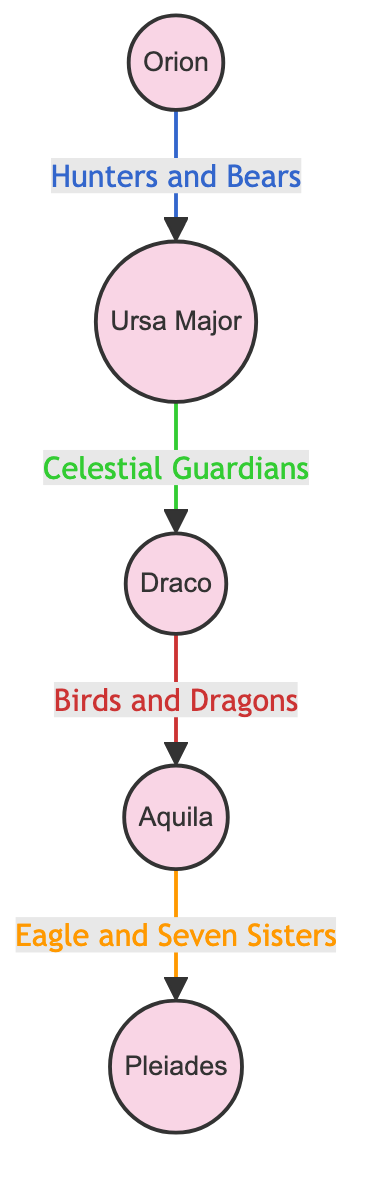What is the first node in the diagram? The first node in the diagram is Orion, as it is positioned at the top and serves as the starting point of the flow.
Answer: Orion How many nodes are present in the diagram? The diagram includes five distinct nodes: Orion, Ursa Major, Draco, Aquila, and Pleiades. Counting each one gives a total of five nodes.
Answer: 5 Which node is connected directly to Ursa Major? Ursa Major is directly connected to Draco, as indicated by the arrow pointing from Ursa Major to Draco in the diagram.
Answer: Draco What does the arrow from Orion to Ursa Major represent? The arrow from Orion to Ursa Major signifies a relationship described as "Hunters and Bears," indicating a mythological connection or grouping between these two constellations.
Answer: Hunters and Bears Which node represents the "Seven Sisters"? The node that represents the "Seven Sisters" is Pleiades, as labeled in the diagram along with Aquila which connects to it.
Answer: Pleiades What is the relationship described between Draco and Aquila? The relationship between Draco and Aquila is described as "Birds and Dragons," which denotes their mythological significance or association in the context of the diagram.
Answer: Birds and Dragons Which two nodes have a connection labeled with a phrase related to guardians? The phrase related to guardians connects Ursa Major and Draco, as shown by the arrow labeled as "Celestial Guardians" between these two nodes.
Answer: Ursa Major and Draco What is the significance of the node labeled Aquila in the diagram? Aquila is significant as it is connected by a relationship labeled "Eagle" with an arrow leading to Pleiades, linking it to a mythological representation of an eagle in the context of a constellation.
Answer: Eagle Which relationship is labeled with the color orange in the diagram? The relationship labeled with the color orange is from Aquila to Pleiades, denoted as "Eagle and Seven Sisters," which reflects their combined mythological significance.
Answer: Eagle and Seven Sisters 